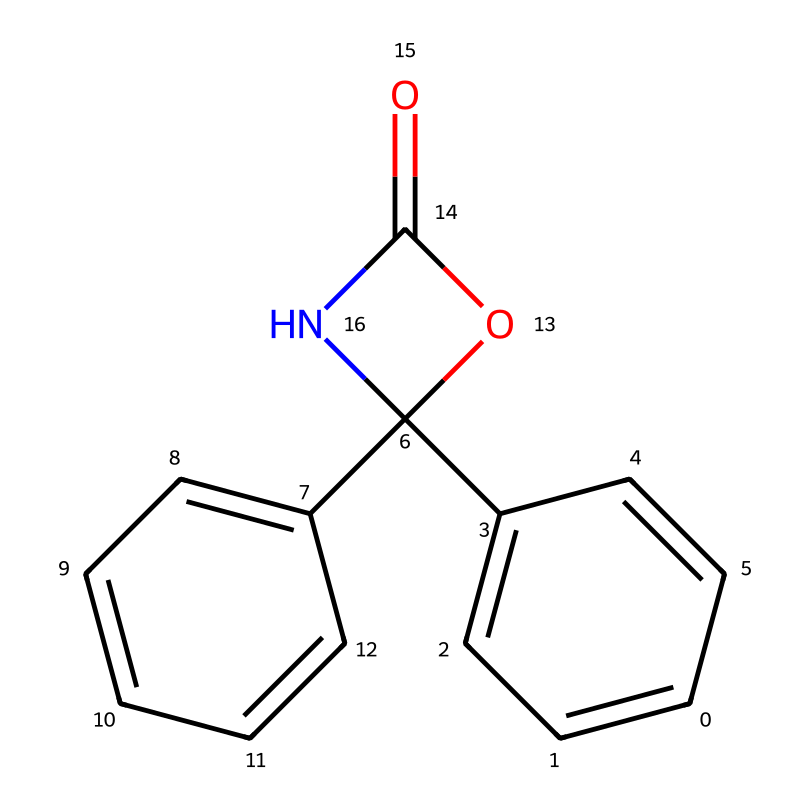What is the main functional group present in this chemical? The presence of a carbonyl group (C=O) adjacent to an amine nitrogen (N) indicates that this chemical has an amide functional group.
Answer: amide How many carbon atoms are in the structure? By breaking down the SMILES representation, we can count a total of 14 carbon atoms that are central to the main structure of the chemical.
Answer: 14 What type of compound is this based on its common usage? Given that this compound is structurally related to chemicals often used for pest control and specifically mentioned as herbicides, it indicates its classification within agrochemicals aimed at weed management.
Answer: herbicide What is the total number of rings in the molecule? Analyzing the structure reveals that there are two fused rings (one large and one smaller), indicating a polycyclic aromatic compound.
Answer: two Does this molecule likely have aromatic properties? The presence of benzene-like structures (indicated by alternating double bonds) throughout the SMILES notation shows that it displays aromatic characteristics.
Answer: yes What is the relationship between the cyclic structures in the molecule? The cyclic structures are fused, meaning they share two carbon atoms between rings, creating a shared boundary in their arrangement, which indicates they are polycyclic.
Answer: fused 